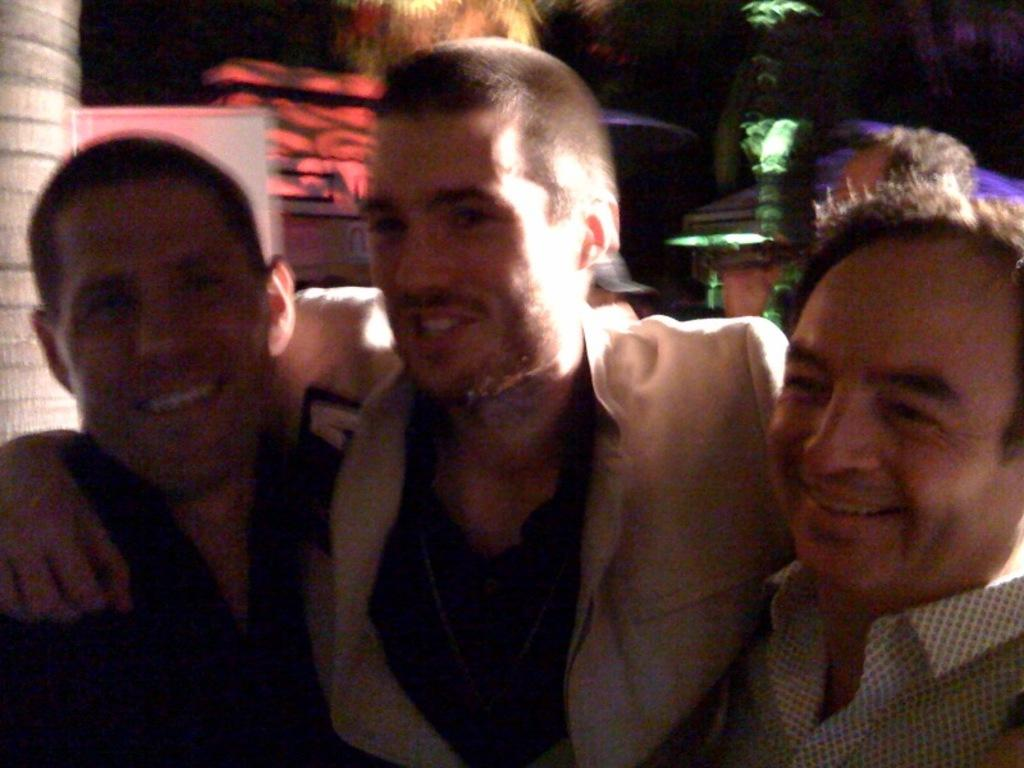What are the persons in the image doing? The persons in the image are holding each other. What can be seen in the background of the image? There are colorful lights in the background of the image. What type of rice can be seen growing on the mountain in the image? There is no mountain or rice present in the image; it features persons holding each other with colorful lights in the background. 